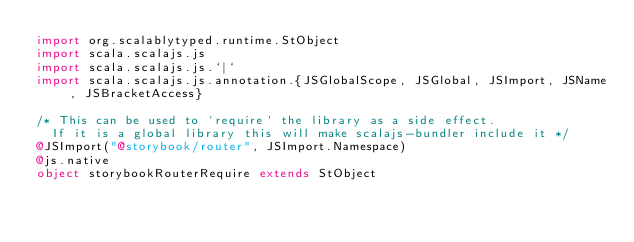<code> <loc_0><loc_0><loc_500><loc_500><_Scala_>import org.scalablytyped.runtime.StObject
import scala.scalajs.js
import scala.scalajs.js.`|`
import scala.scalajs.js.annotation.{JSGlobalScope, JSGlobal, JSImport, JSName, JSBracketAccess}

/* This can be used to `require` the library as a side effect.
  If it is a global library this will make scalajs-bundler include it */
@JSImport("@storybook/router", JSImport.Namespace)
@js.native
object storybookRouterRequire extends StObject
</code> 